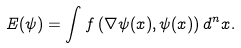Convert formula to latex. <formula><loc_0><loc_0><loc_500><loc_500>E ( \psi ) = \int f \left ( \nabla \psi ( x ) , \psi ( x ) \right ) d ^ { n } x .</formula> 